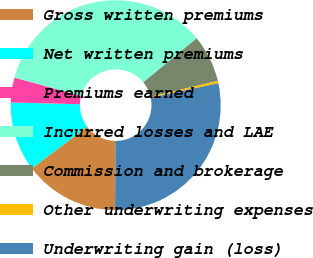Convert chart. <chart><loc_0><loc_0><loc_500><loc_500><pie_chart><fcel>Gross written premiums<fcel>Net written premiums<fcel>Premiums earned<fcel>Incurred losses and LAE<fcel>Commission and brokerage<fcel>Other underwriting expenses<fcel>Underwriting gain (loss)<nl><fcel>14.61%<fcel>10.7%<fcel>3.82%<fcel>34.79%<fcel>7.26%<fcel>0.38%<fcel>28.44%<nl></chart> 